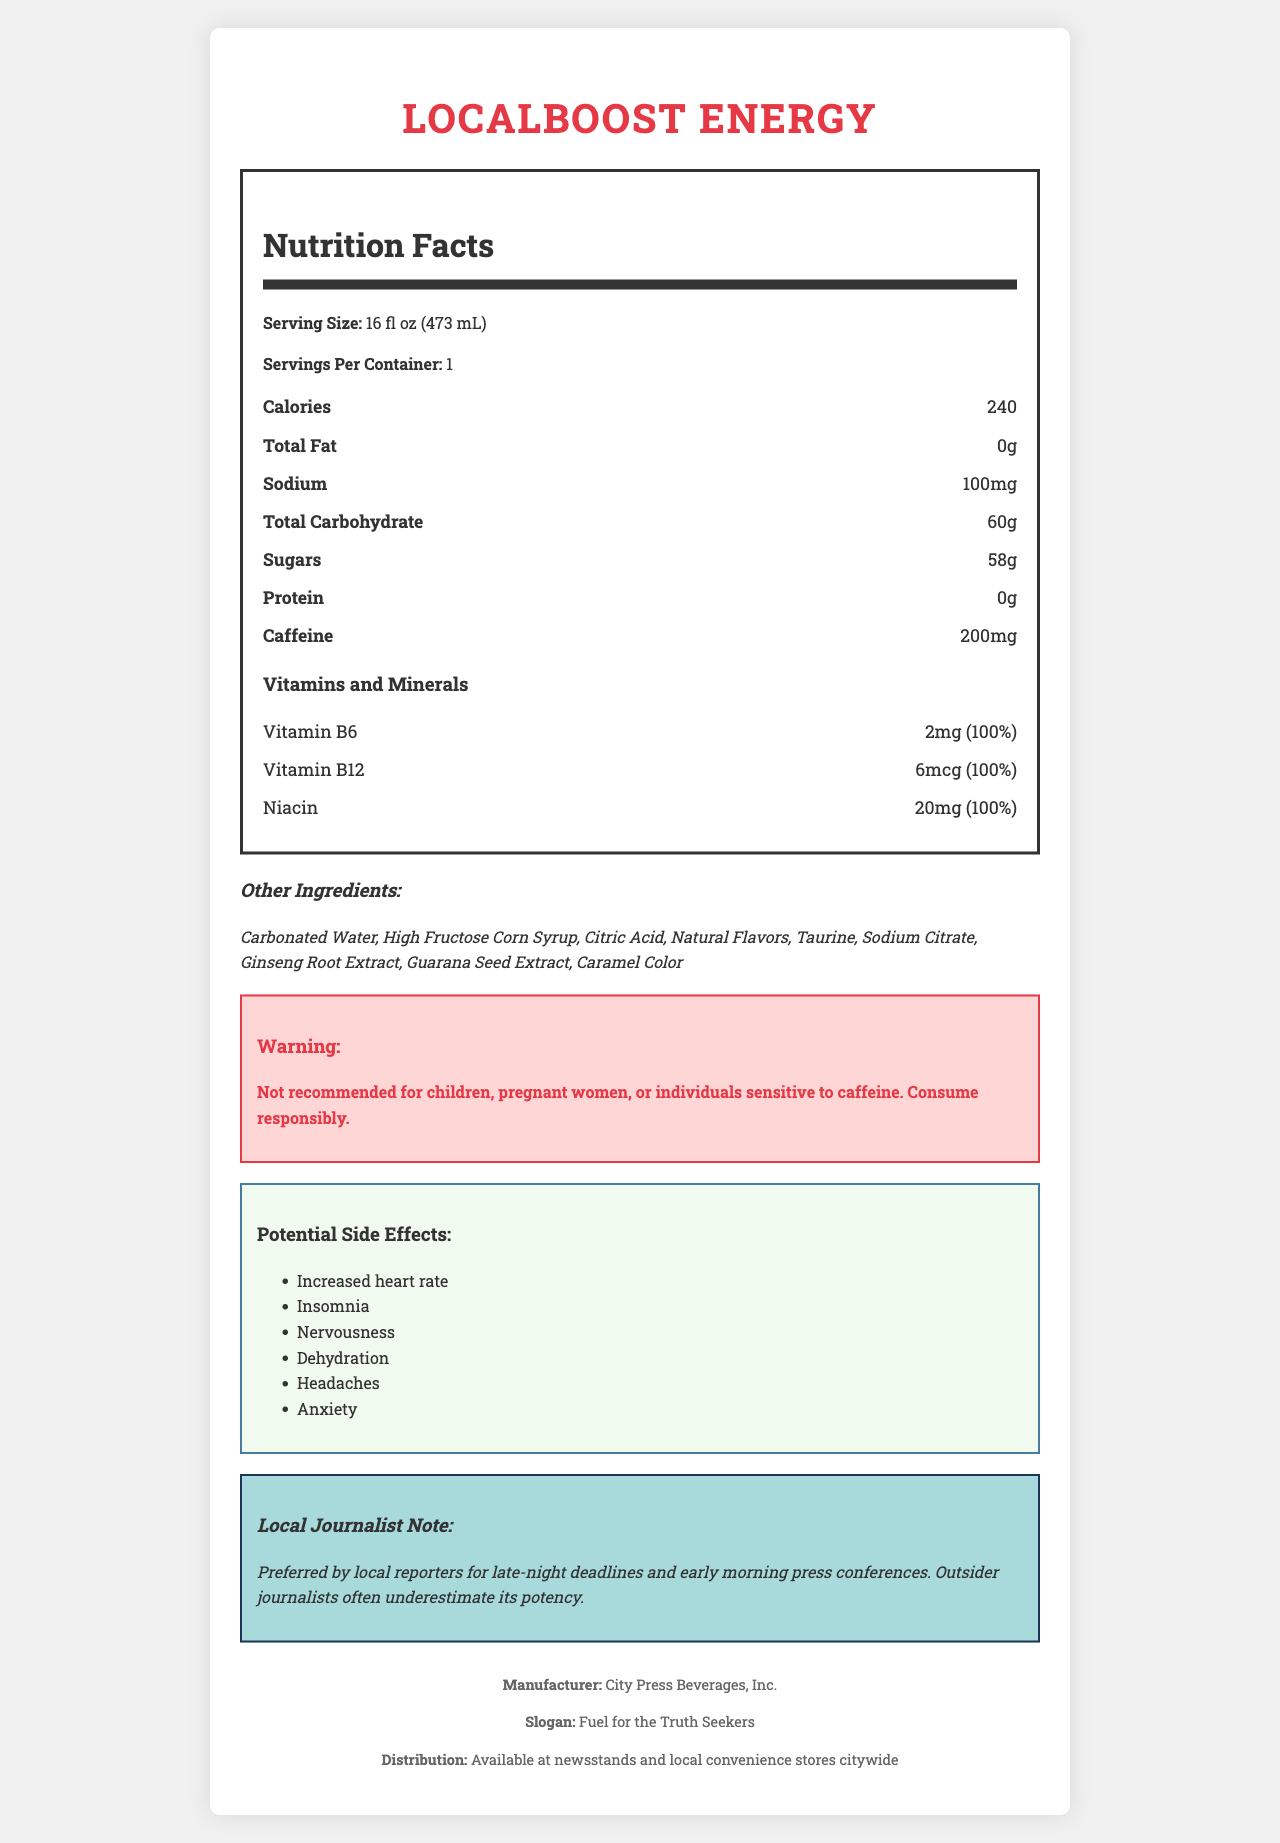what is the serving size? The serving size is directly listed under the nutrition facts section of the document.
Answer: 16 fl oz (473 mL) how many calories are in one container? The document states there are 240 calories per container.
Answer: 240 how much caffeine is present in one serving? Under the nutrition facts section, caffeine content is specified as 200mg per serving.
Answer: 200mg name two vitamins included and their daily values The vitamins section lists Vitamin B6 with a daily value of 100% and Vitamin B12 also with a daily value of 100%.
Answer: Vitamin B6 (100%), Vitamin B12 (100%) what is the company slogan? The slogan is mentioned at the bottom of the document.
Answer: Fuel for the Truth Seekers which side effect is not listed in the document? A. Increased heart rate B. Dizziness C. Insomnia D. Headaches The document lists side effects, and dizziness is not among them.
Answer: B which ingredient is the second on the list of other ingredients? A. Citric Acid B. High Fructose Corn Syrup C. Sodium Citrate D. Ginseng Root Extract The second item on the other ingredients list is High Fructose Corn Syrup.
Answer: B is this drink recommended for children? The warning section states it is not recommended for children.
Answer: No who manufactures LocalBoost Energy? Manufacturer information is provided at the bottom of the document.
Answer: City Press Beverages, Inc. summarize the main idea of the document The document serves to inform about the nutritional content and warnings associated with LocalBoost Energy, highlighting its ingredients and side effects, and giving some contextual usage information specific to local reporters.
Answer: The document provides detailed nutrition facts for LocalBoost Energy, a popular energy drink for local journalists. It includes information about serving size, calorie count, caffeine content, ingredients, vitamins, potential side effects, and specific warnings. It also mentions its manufacturer, distribution, and a note emphasizing its preference among local journalists. how many grams of sugars are there in one serving? The nutrition facts section lists 58 grams of sugars per serving.
Answer: 58g what is the preferred use of this product among local journalists? This is mentioned in the local journalist note section.
Answer: For late-night deadlines and early morning press conferences. how much sodium is present per container? The nutrition facts section shows 100mg of sodium per container.
Answer: 100mg what is the daily value percentage of Niacin provided? The vitamins and minerals section lists Niacin with a daily value of 100%.
Answer: 100% does the document state the manufacturing company address? The document does not provide the address of the manufacturing company.
Answer: Cannot be determined what is the distribution channel for LocalBoost Energy? The distribution information is mentioned at the bottom of the document.
Answer: Available at newsstands and local convenience stores citywide 